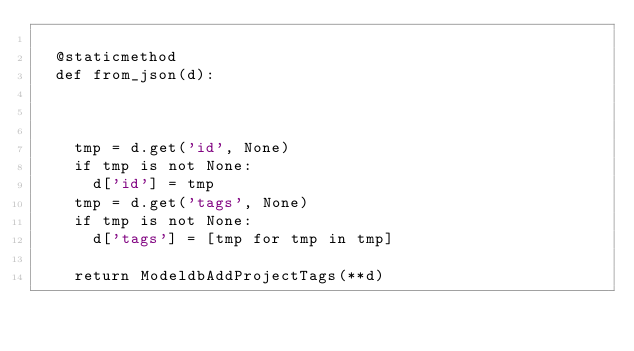Convert code to text. <code><loc_0><loc_0><loc_500><loc_500><_Python_>
  @staticmethod
  def from_json(d):
    
    

    tmp = d.get('id', None)
    if tmp is not None:
      d['id'] = tmp
    tmp = d.get('tags', None)
    if tmp is not None:
      d['tags'] = [tmp for tmp in tmp]

    return ModeldbAddProjectTags(**d)
</code> 